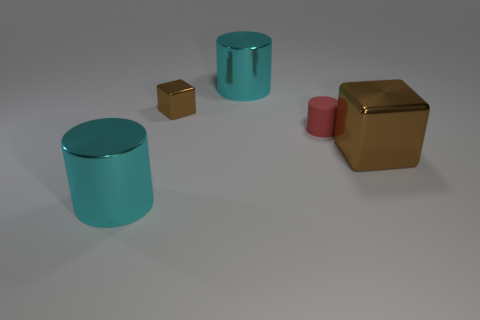Is there any other thing that has the same color as the large cube? Indeed, there is an object sharing the large cube's rich golden hue. It's the smaller cube located near the center. 